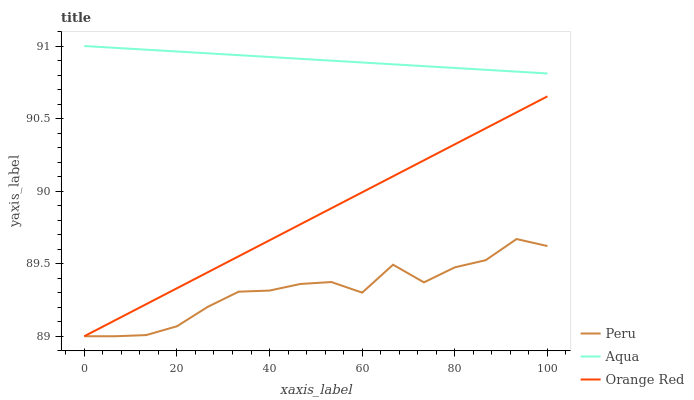Does Peru have the minimum area under the curve?
Answer yes or no. Yes. Does Aqua have the maximum area under the curve?
Answer yes or no. Yes. Does Orange Red have the minimum area under the curve?
Answer yes or no. No. Does Orange Red have the maximum area under the curve?
Answer yes or no. No. Is Aqua the smoothest?
Answer yes or no. Yes. Is Peru the roughest?
Answer yes or no. Yes. Is Orange Red the smoothest?
Answer yes or no. No. Is Orange Red the roughest?
Answer yes or no. No. Does Aqua have the highest value?
Answer yes or no. Yes. Does Orange Red have the highest value?
Answer yes or no. No. Is Orange Red less than Aqua?
Answer yes or no. Yes. Is Aqua greater than Orange Red?
Answer yes or no. Yes. Does Orange Red intersect Aqua?
Answer yes or no. No. 